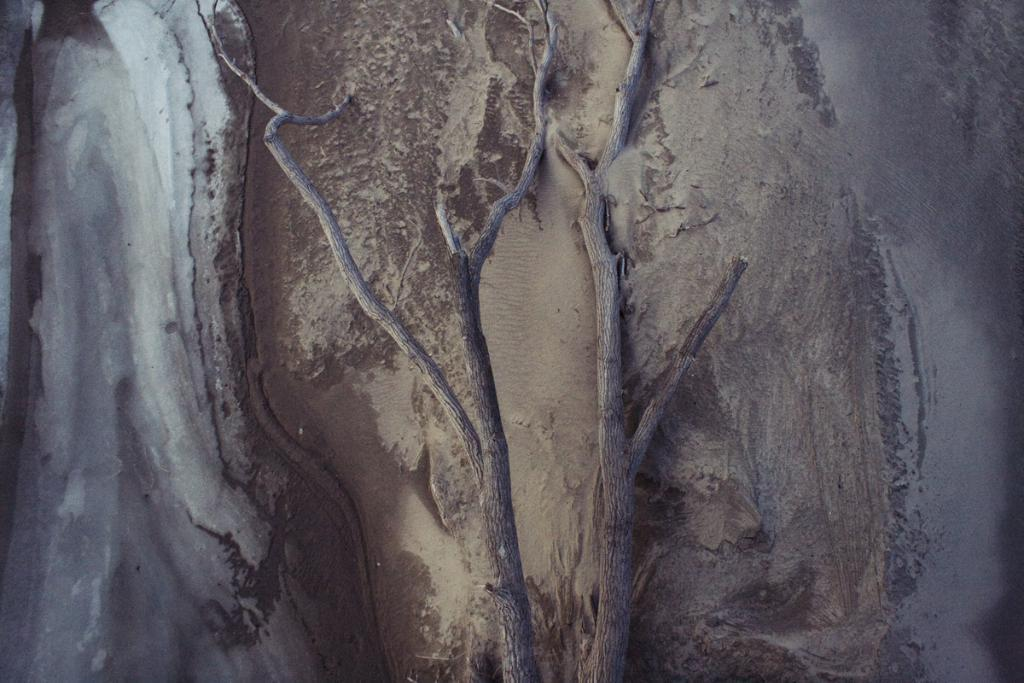What is the main object in the image? There is a tree in the image. What is the color of the tree? The tree is brown in color. What is the condition of the tree in the image? The tree is fallen on the sand. What can be seen on the left side of the image? There is mud on the left side of the image. What are the colors of the mud? The mud is brown and white in color. How many goldfish are swimming in the mud on the left side of the image? There are no goldfish present in the image; it features a fallen tree and mud. What type of key is used to unlock the tree in the image? There is no key or locking mechanism present in the image; it is a fallen tree on the sand. 